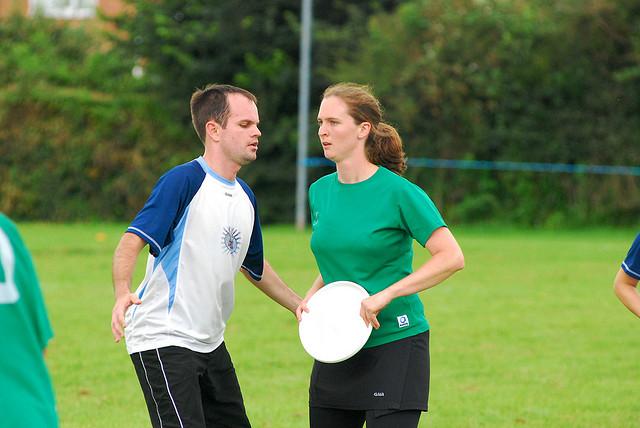What is the lady holding?
Write a very short answer. Frisbee. How many stripes are on the guys shorts?
Short answer required. 2. Is he going to throw the frisbee?
Be succinct. No. Is she having fun?
Be succinct. Yes. What does the woman have in her hand?
Give a very brief answer. Frisbee. Are they fighting over the frisbee?
Write a very short answer. No. 